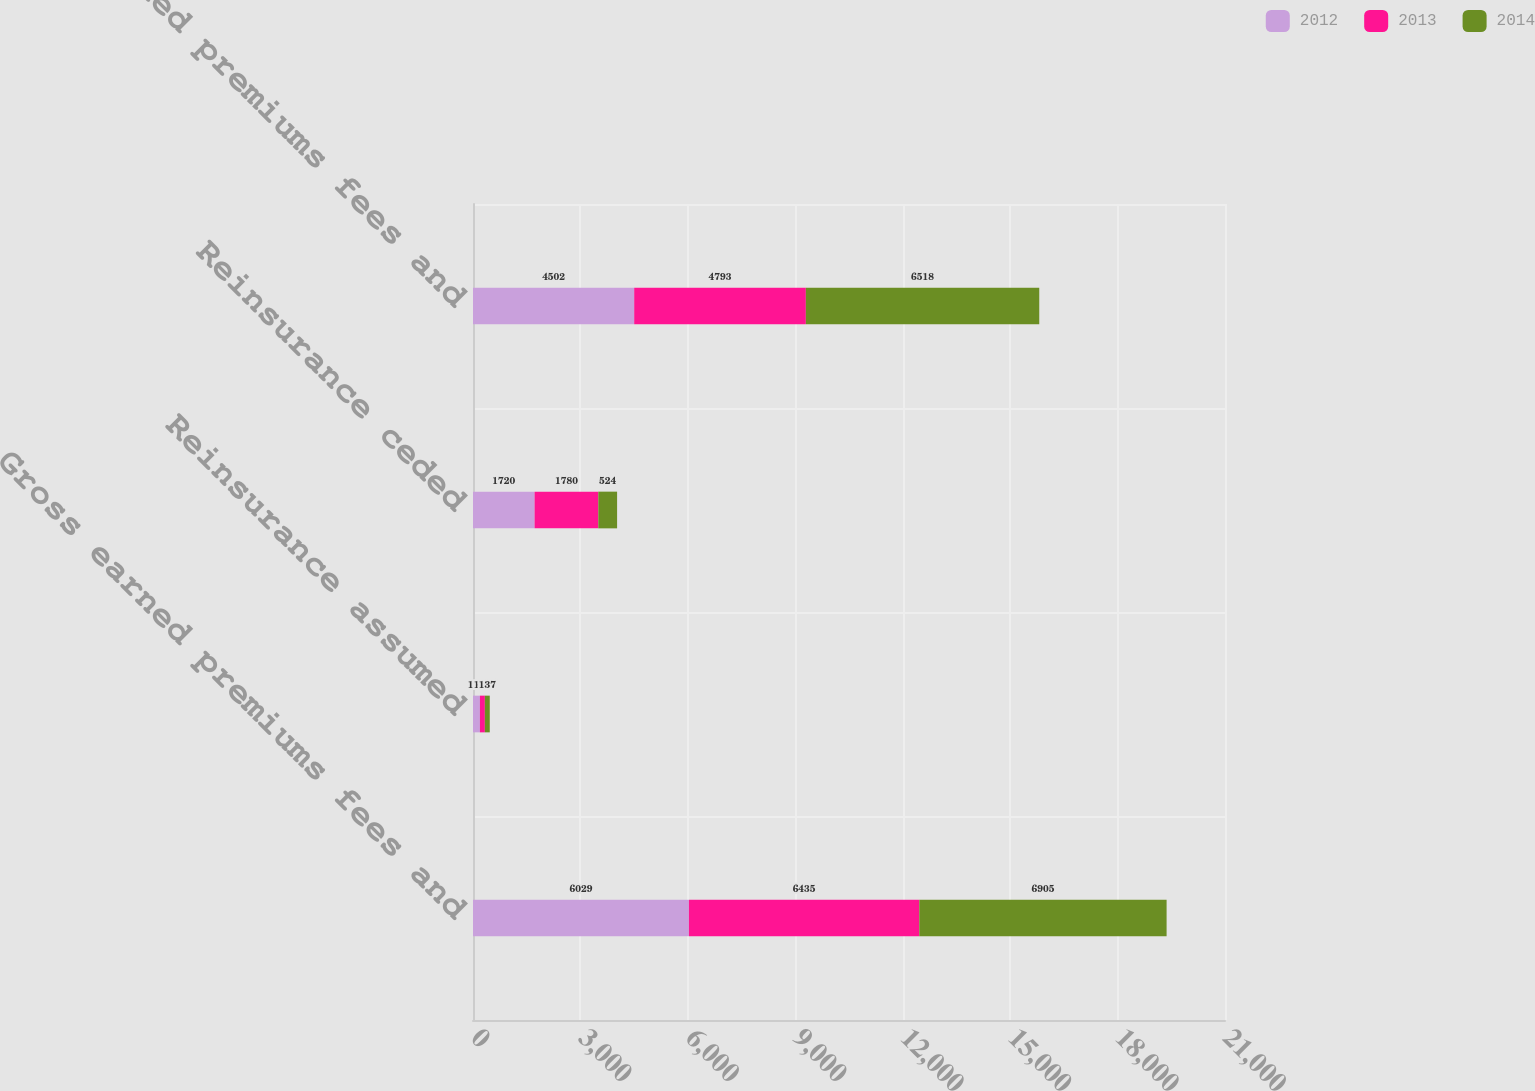Convert chart to OTSL. <chart><loc_0><loc_0><loc_500><loc_500><stacked_bar_chart><ecel><fcel>Gross earned premiums fees and<fcel>Reinsurance assumed<fcel>Reinsurance ceded<fcel>Net earned premiums fees and<nl><fcel>2012<fcel>6029<fcel>193<fcel>1720<fcel>4502<nl><fcel>2013<fcel>6435<fcel>138<fcel>1780<fcel>4793<nl><fcel>2014<fcel>6905<fcel>137<fcel>524<fcel>6518<nl></chart> 